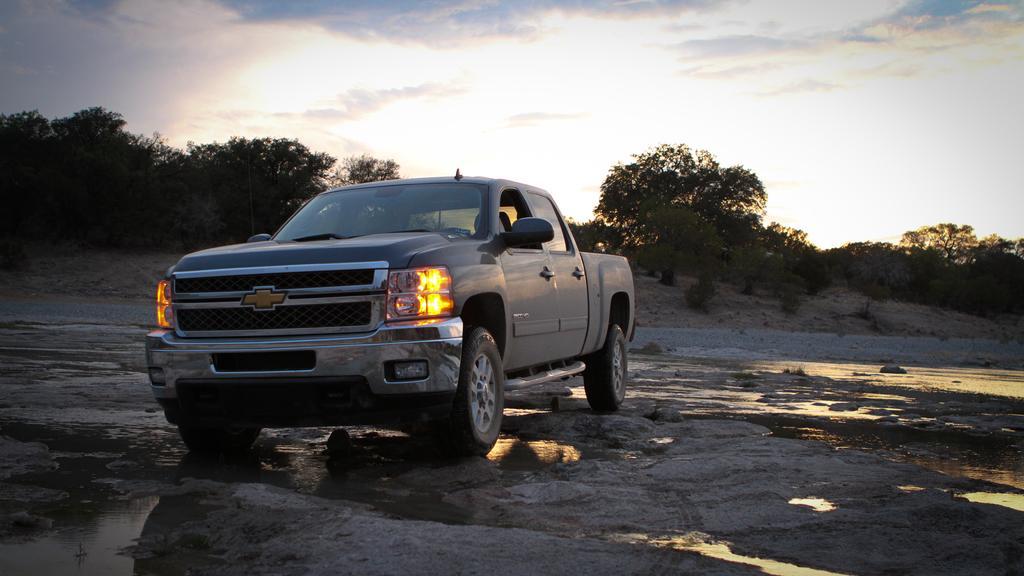Please provide a concise description of this image. In the image we can see a vehicle and these are the headlights of the vehicle. Here we can see the water, trees and the cloudy sky. 